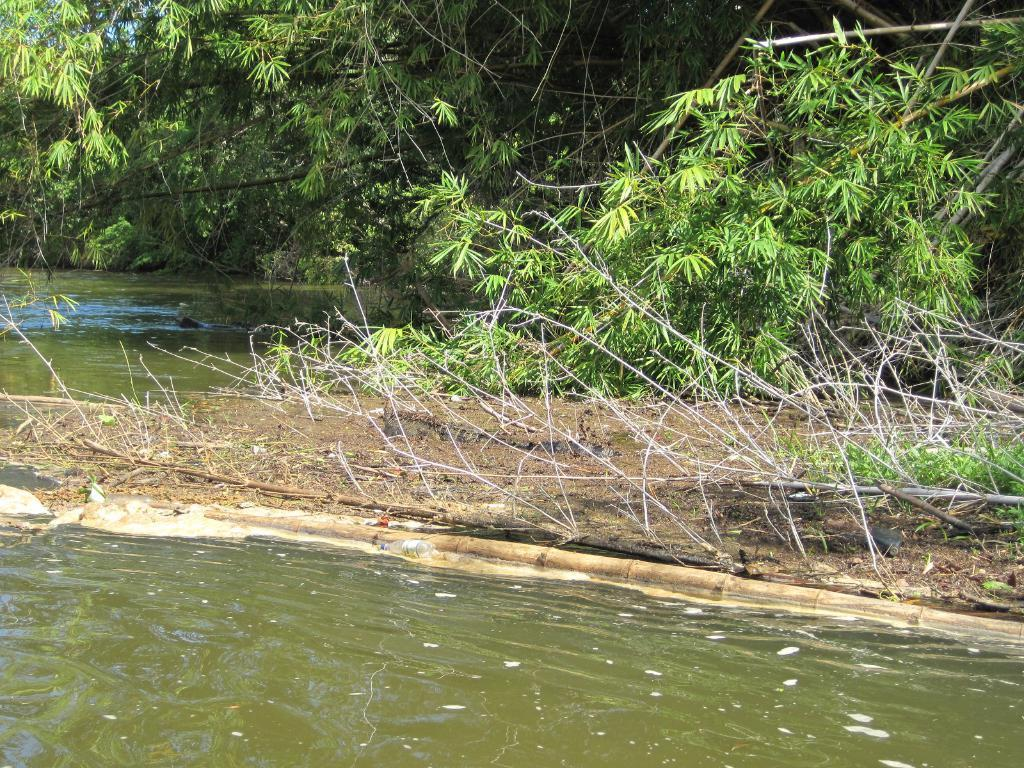What type of vegetation can be seen in the image? There is a group of trees in the image. What can be seen in the foreground of the image? There is water visible in the foreground of the image. How many potatoes are floating in the water in the image? There are no potatoes present in the image. What type of notebook can be seen lying on the ground near the trees in the image? There is no notebook present in the image. 